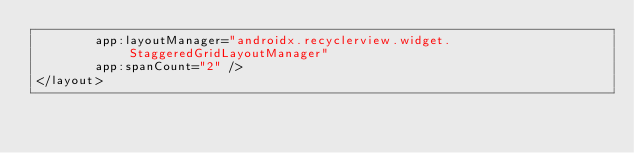<code> <loc_0><loc_0><loc_500><loc_500><_XML_>        app:layoutManager="androidx.recyclerview.widget.StaggeredGridLayoutManager"
        app:spanCount="2" />
</layout>
</code> 